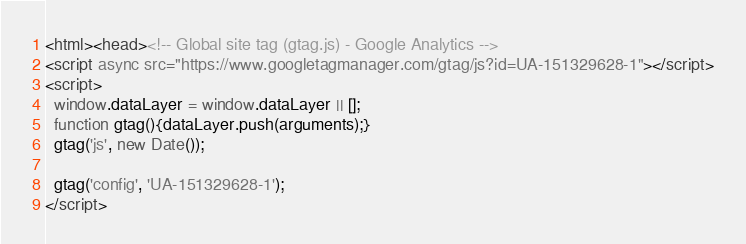Convert code to text. <code><loc_0><loc_0><loc_500><loc_500><_HTML_><html><head><!-- Global site tag (gtag.js) - Google Analytics -->
<script async src="https://www.googletagmanager.com/gtag/js?id=UA-151329628-1"></script>
<script>
  window.dataLayer = window.dataLayer || [];
  function gtag(){dataLayer.push(arguments);}
  gtag('js', new Date());

  gtag('config', 'UA-151329628-1');
</script></code> 